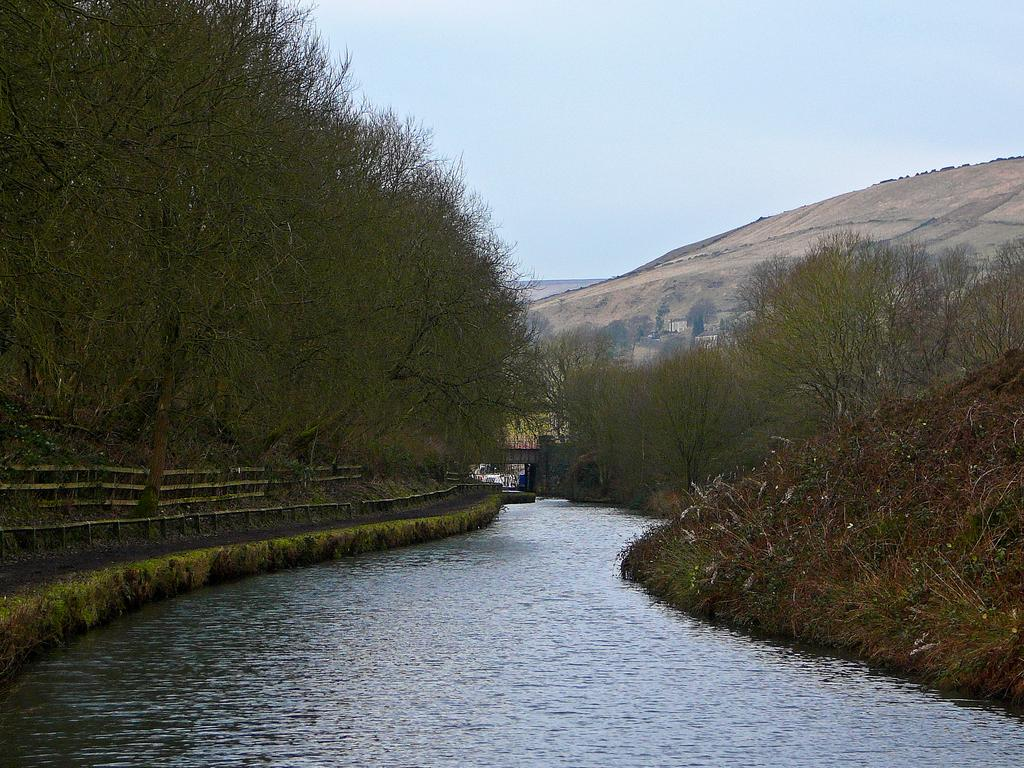What is the primary element visible in the image? There is water in the image. What can be seen on the left side of the image? There are trees and railings on the left side of the image. What is present on the right side of the image? There are trees and plants on the right side of the image. What can be seen in the background of the image? There are hills, a bridge, and the sky visible in the background of the image. How many bears are sitting on the rocks in the image? There are no bears or rocks present in the image. What type of birds can be seen flying over the bridge in the image? There are no birds visible in the image; only the water, trees, railings, plants, hills, bridge, and sky are present. 